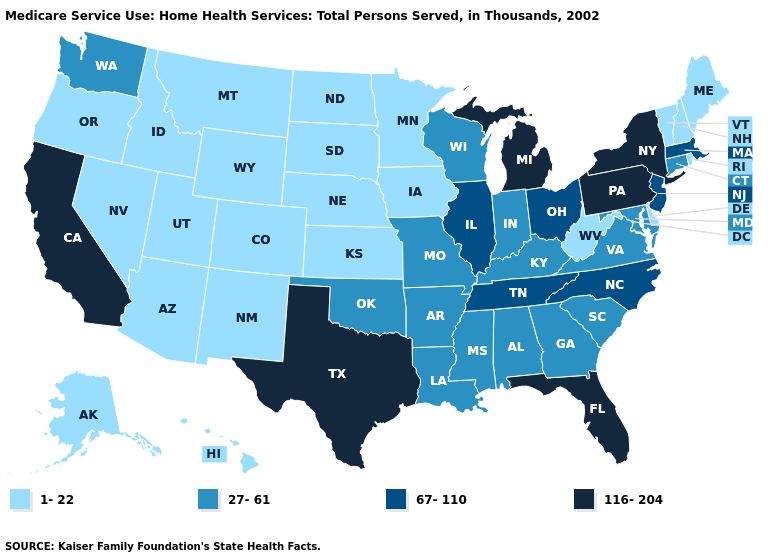Name the states that have a value in the range 27-61?
Be succinct. Alabama, Arkansas, Connecticut, Georgia, Indiana, Kentucky, Louisiana, Maryland, Mississippi, Missouri, Oklahoma, South Carolina, Virginia, Washington, Wisconsin. What is the highest value in the South ?
Concise answer only. 116-204. What is the value of Maryland?
Be succinct. 27-61. Which states hav the highest value in the MidWest?
Quick response, please. Michigan. What is the value of South Carolina?
Keep it brief. 27-61. Which states have the highest value in the USA?
Write a very short answer. California, Florida, Michigan, New York, Pennsylvania, Texas. Which states have the highest value in the USA?
Concise answer only. California, Florida, Michigan, New York, Pennsylvania, Texas. What is the value of Vermont?
Short answer required. 1-22. Does Hawaii have the same value as Pennsylvania?
Short answer required. No. What is the value of Wyoming?
Give a very brief answer. 1-22. What is the highest value in states that border Montana?
Concise answer only. 1-22. Does Washington have a lower value than Ohio?
Answer briefly. Yes. What is the value of Missouri?
Concise answer only. 27-61. Name the states that have a value in the range 67-110?
Be succinct. Illinois, Massachusetts, New Jersey, North Carolina, Ohio, Tennessee. 